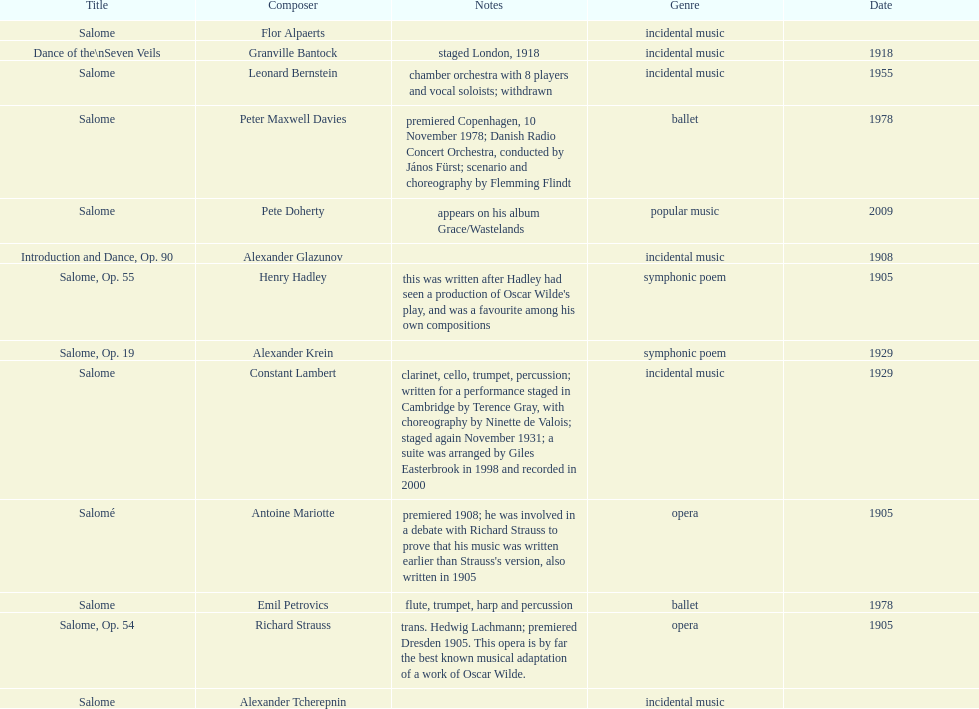What work was written after henry hadley had seen an oscar wilde play? Salome, Op. 55. 